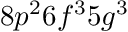Convert formula to latex. <formula><loc_0><loc_0><loc_500><loc_500>8 p ^ { 2 } 6 f ^ { 3 } 5 g ^ { 3 }</formula> 